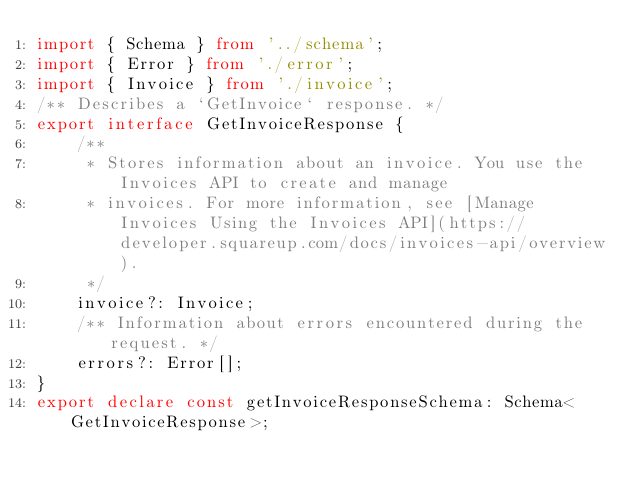Convert code to text. <code><loc_0><loc_0><loc_500><loc_500><_TypeScript_>import { Schema } from '../schema';
import { Error } from './error';
import { Invoice } from './invoice';
/** Describes a `GetInvoice` response. */
export interface GetInvoiceResponse {
    /**
     * Stores information about an invoice. You use the Invoices API to create and manage
     * invoices. For more information, see [Manage Invoices Using the Invoices API](https://developer.squareup.com/docs/invoices-api/overview).
     */
    invoice?: Invoice;
    /** Information about errors encountered during the request. */
    errors?: Error[];
}
export declare const getInvoiceResponseSchema: Schema<GetInvoiceResponse>;
</code> 